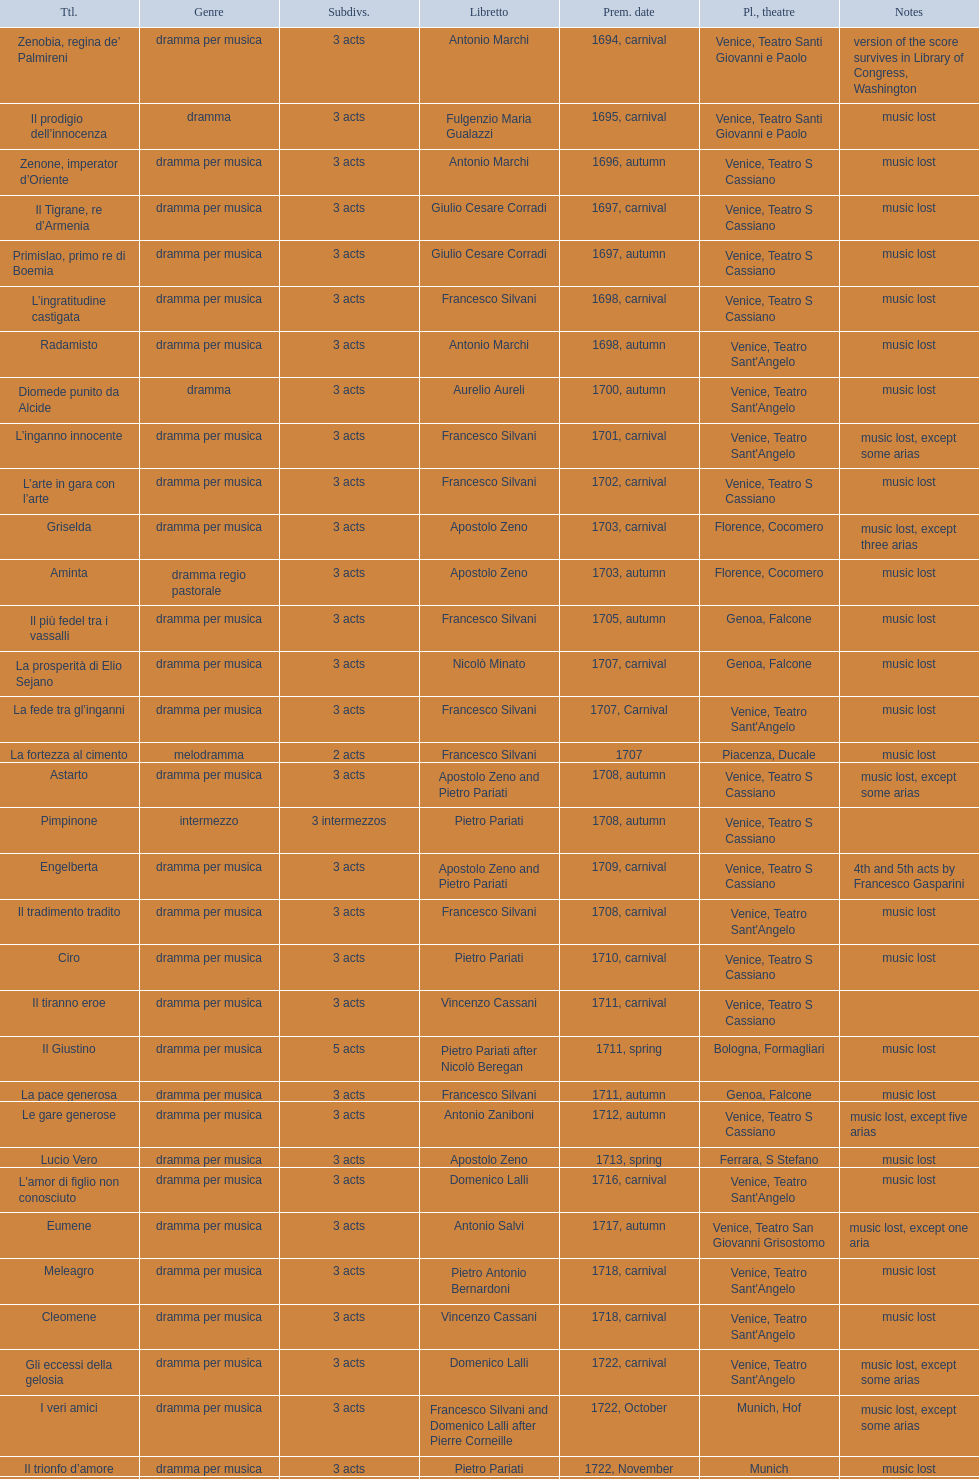Which title premiered directly after candalide? Artamene. 